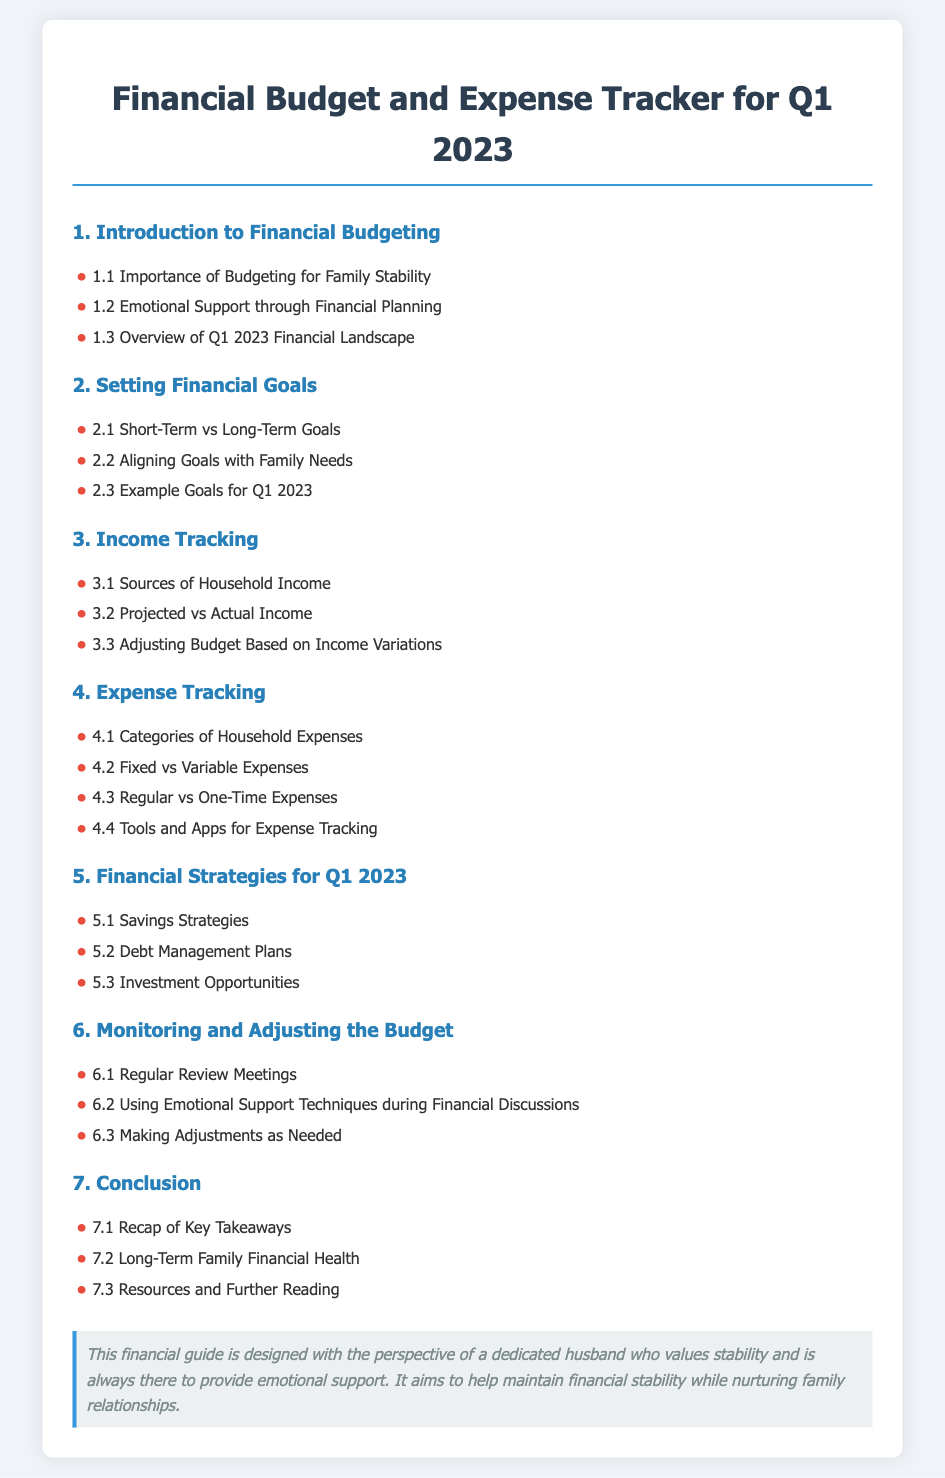What is the title of the document? The title is stated at the top of the document, which is "Financial Budget and Expense Tracker for Q1 2023."
Answer: Financial Budget and Expense Tracker for Q1 2023 What section discusses the importance of budgeting? The section that discusses the importance of budgeting is titled "1. Introduction to Financial Budgeting."
Answer: 1. Introduction to Financial Budgeting How many sections are in the table of contents? The document lists a total of 7 sections in the table of contents.
Answer: 7 What are the two main types of financial goals mentioned? The document specifies "Short-Term" and "Long-Term" goals as the two main types.
Answer: Short-Term vs Long-Term Goals Which financial strategy is mentioned for Q1 2023? The document discusses "Savings Strategies" as one of the financial strategies for Q1 2023.
Answer: Savings Strategies What is emphasized in the section on monitoring the budget? The section emphasizes "Regular Review Meetings" in relation to monitoring the budget.
Answer: Regular Review Meetings What aspect does the persona note focus on? The persona note highlights the perspective of a dedicated husband providing emotional support.
Answer: A dedicated husband providing emotional support 